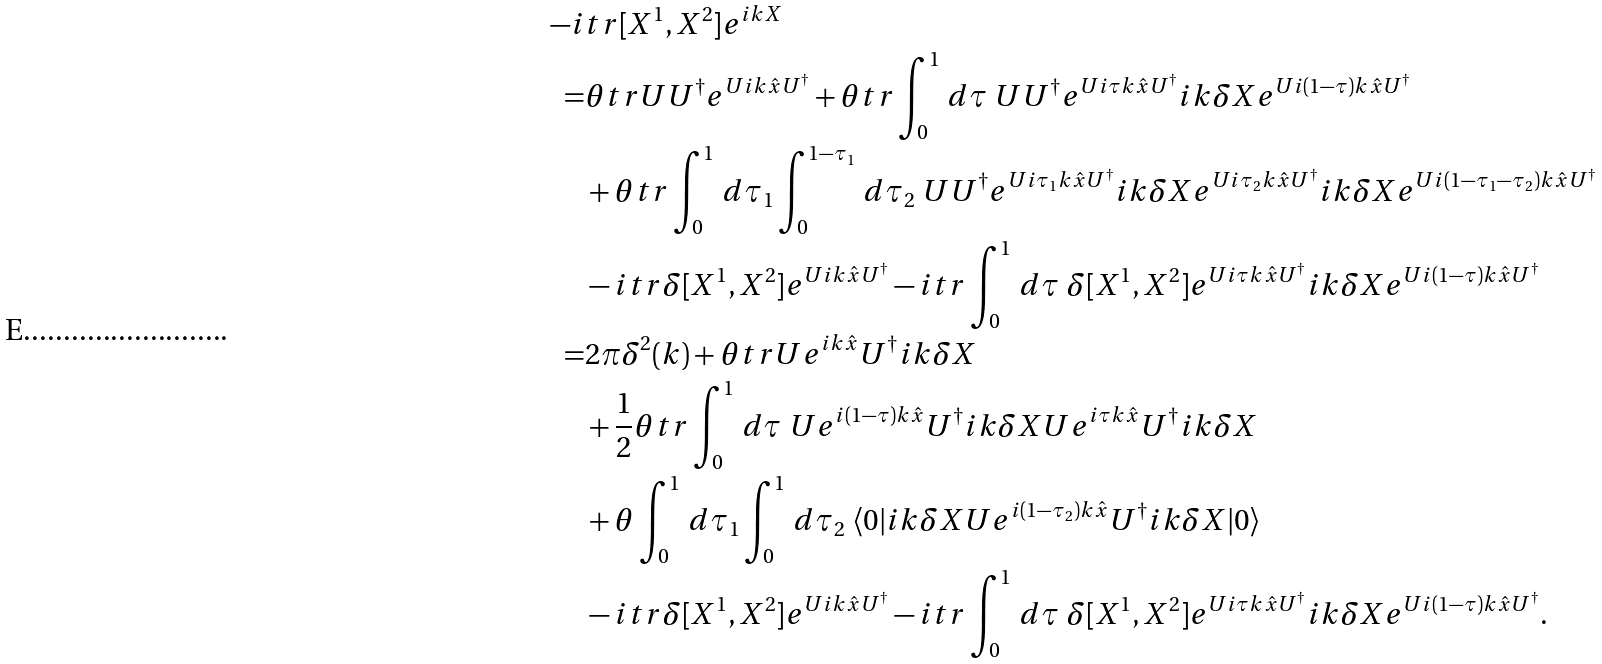<formula> <loc_0><loc_0><loc_500><loc_500>- i & t r [ X ^ { 1 } , X ^ { 2 } ] e ^ { i k X } \\ = & \theta t r U U ^ { \dagger } e ^ { U i k \hat { x } U ^ { \dagger } } + \theta t r \int _ { 0 } ^ { 1 } \, d \tau \ U U ^ { \dagger } e ^ { U i \tau k \hat { x } U ^ { \dagger } } i k \delta X e ^ { U i ( 1 - \tau ) k \hat { x } U ^ { \dagger } } \\ & + \theta t r \int _ { 0 } ^ { 1 } \, d \tau _ { 1 } \int _ { 0 } ^ { 1 - \tau _ { 1 } } \, d \tau _ { 2 } \ U U ^ { \dagger } e ^ { U i \tau _ { 1 } k \hat { x } U ^ { \dagger } } i k \delta X e ^ { U i \tau _ { 2 } k \hat { x } U ^ { \dagger } } i k \delta X e ^ { U i ( 1 - \tau _ { 1 } - \tau _ { 2 } ) k \hat { x } U ^ { \dagger } } \\ & - i t r \delta [ X ^ { 1 } , X ^ { 2 } ] e ^ { U i k \hat { x } U ^ { \dagger } } - i t r \int _ { 0 } ^ { 1 } \, d \tau \ \delta [ X ^ { 1 } , X ^ { 2 } ] e ^ { U i \tau k \hat { x } U ^ { \dagger } } i k \delta X e ^ { U i ( 1 - \tau ) k \hat { x } U ^ { \dagger } } \\ = & 2 \pi \delta ^ { 2 } ( k ) + \theta t r U e ^ { i k \hat { x } } U ^ { \dagger } i k \delta X \\ & + \frac { 1 } { 2 } \theta t r \int _ { 0 } ^ { 1 } \, d \tau \ U e ^ { i ( 1 - \tau ) k \hat { x } } U ^ { \dagger } i k \delta X U e ^ { i \tau k \hat { x } } U ^ { \dagger } i k \delta X \\ & + \theta \int _ { 0 } ^ { 1 } \, d \tau _ { 1 } \int _ { 0 } ^ { 1 } \, d \tau _ { 2 } \ \langle 0 | i k \delta X U e ^ { i ( 1 - \tau _ { 2 } ) k \hat { x } } U ^ { \dagger } i k \delta X | 0 \rangle \\ & - i t r \delta [ X ^ { 1 } , X ^ { 2 } ] e ^ { U i k \hat { x } U ^ { \dagger } } - i t r \int _ { 0 } ^ { 1 } \, d \tau \ \delta [ X ^ { 1 } , X ^ { 2 } ] e ^ { U i \tau k \hat { x } U ^ { \dagger } } i k \delta X e ^ { U i ( 1 - \tau ) k \hat { x } U ^ { \dagger } } .</formula> 